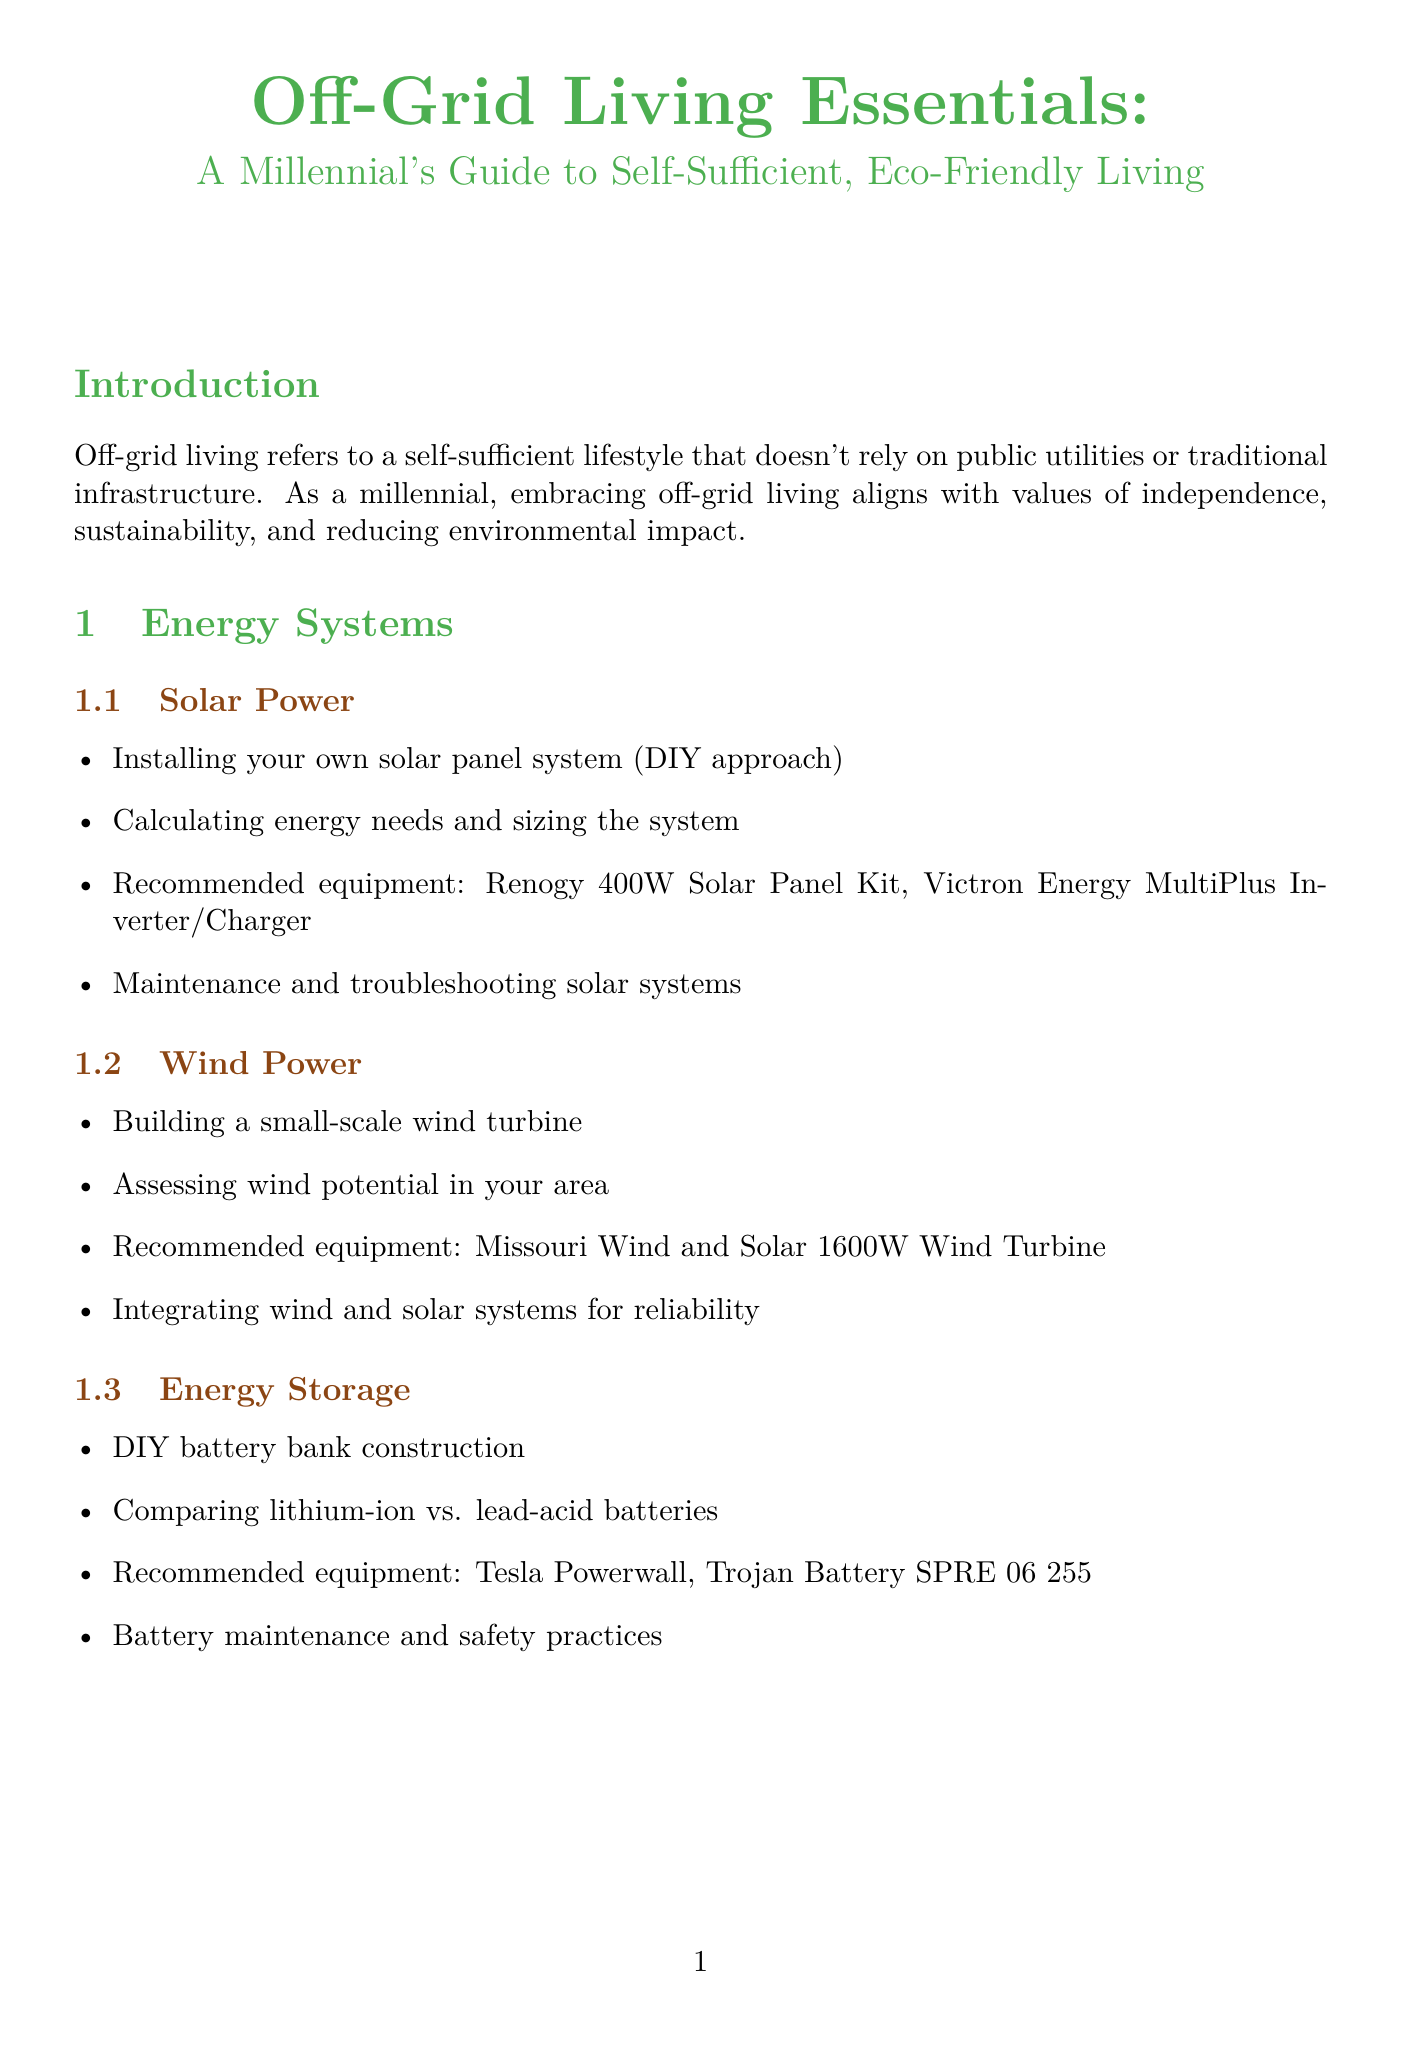What is the title of the manual? The title is stated at the beginning of the document.
Answer: Off-Grid Living Essentials: A Millennial's Guide to Self-Sufficient, Eco-Friendly Living What is one recommended equipment for solar power? The section on solar power includes a list of recommended equipment.
Answer: Renogy 400W Solar Panel Kit What is one method for filtration in rainwater harvesting? The content on rainwater harvesting outlines filtration methods.
Answer: slow sand filters Which fish species is suggested for aquaponics? The section on aquaponics specifies suitable fish species.
Answer: tilapia What is a key component in building a composting toilet? The section on composting toilets highlights necessary steps.
Answer: Building a DIY composting toilet How many classes are there for ham radio licensing? The emergency communication section mentions the categories of licensing.
Answer: Three What is the purpose of a biogas digester? The content of the biogas digester section explains its uses.
Answer: Cooking and lighting What is a resource recommended for understanding zero waste lifestyle? The zero waste lifestyle section provides external resources.
Answer: Zero Waste Home by Bea Johnson What is an example of a mobile hotspot mentioned? The internet access section lists specific mobile hotspots.
Answer: Verizon Jetpack What should you do before constructing alternative systems? The zoning and building codes section explains necessary preliminary steps.
Answer: Obtain necessary permits 